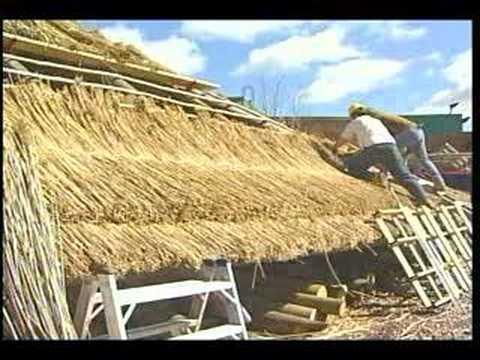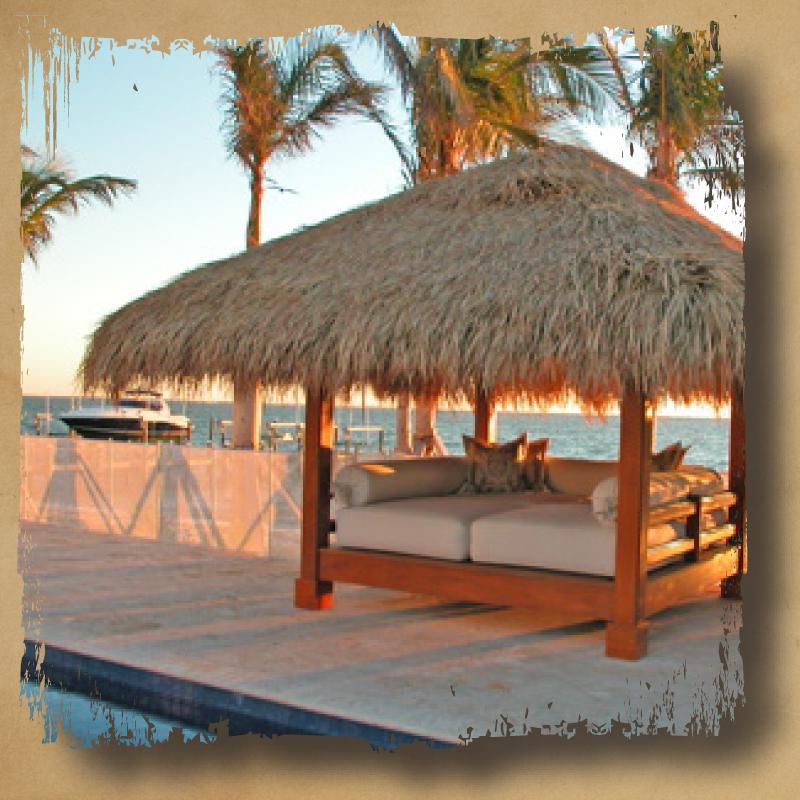The first image is the image on the left, the second image is the image on the right. Assess this claim about the two images: "One image shows a structure with at least one peaked roof held up by beams and with open sides, in front of a body of water". Correct or not? Answer yes or no. Yes. The first image is the image on the left, the second image is the image on the right. Analyze the images presented: Is the assertion "A round hut with a round grass roof can be seen." valid? Answer yes or no. No. 